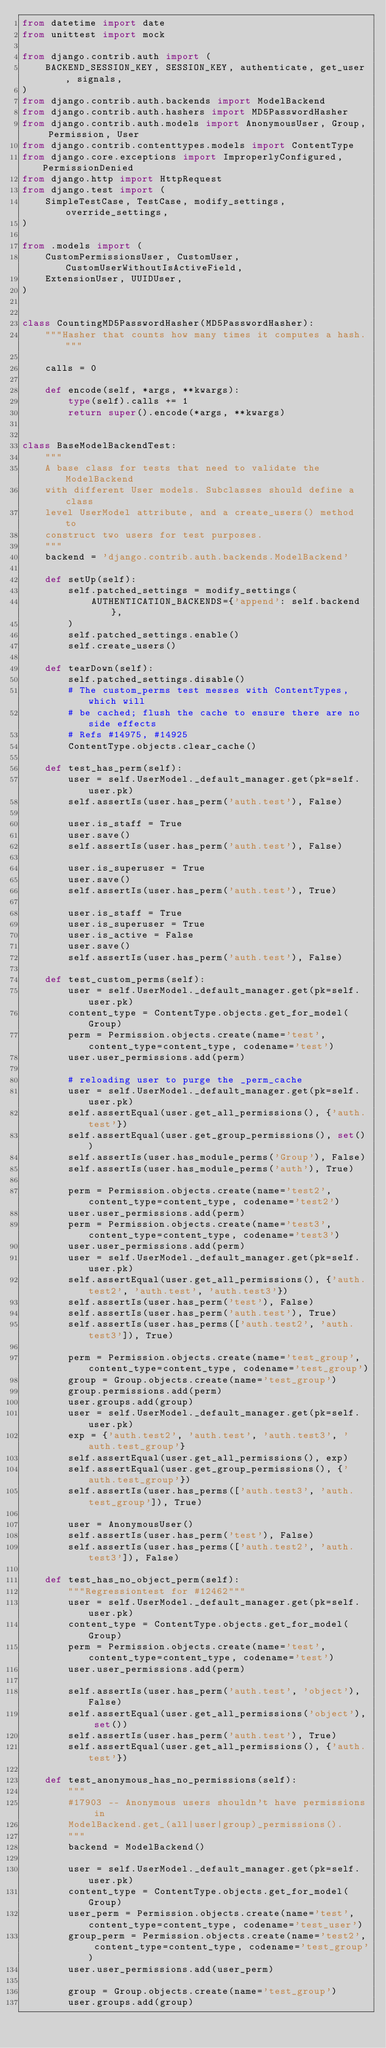<code> <loc_0><loc_0><loc_500><loc_500><_Python_>from datetime import date
from unittest import mock

from django.contrib.auth import (
    BACKEND_SESSION_KEY, SESSION_KEY, authenticate, get_user, signals,
)
from django.contrib.auth.backends import ModelBackend
from django.contrib.auth.hashers import MD5PasswordHasher
from django.contrib.auth.models import AnonymousUser, Group, Permission, User
from django.contrib.contenttypes.models import ContentType
from django.core.exceptions import ImproperlyConfigured, PermissionDenied
from django.http import HttpRequest
from django.test import (
    SimpleTestCase, TestCase, modify_settings, override_settings,
)

from .models import (
    CustomPermissionsUser, CustomUser, CustomUserWithoutIsActiveField,
    ExtensionUser, UUIDUser,
)


class CountingMD5PasswordHasher(MD5PasswordHasher):
    """Hasher that counts how many times it computes a hash."""

    calls = 0

    def encode(self, *args, **kwargs):
        type(self).calls += 1
        return super().encode(*args, **kwargs)


class BaseModelBackendTest:
    """
    A base class for tests that need to validate the ModelBackend
    with different User models. Subclasses should define a class
    level UserModel attribute, and a create_users() method to
    construct two users for test purposes.
    """
    backend = 'django.contrib.auth.backends.ModelBackend'

    def setUp(self):
        self.patched_settings = modify_settings(
            AUTHENTICATION_BACKENDS={'append': self.backend},
        )
        self.patched_settings.enable()
        self.create_users()

    def tearDown(self):
        self.patched_settings.disable()
        # The custom_perms test messes with ContentTypes, which will
        # be cached; flush the cache to ensure there are no side effects
        # Refs #14975, #14925
        ContentType.objects.clear_cache()

    def test_has_perm(self):
        user = self.UserModel._default_manager.get(pk=self.user.pk)
        self.assertIs(user.has_perm('auth.test'), False)

        user.is_staff = True
        user.save()
        self.assertIs(user.has_perm('auth.test'), False)

        user.is_superuser = True
        user.save()
        self.assertIs(user.has_perm('auth.test'), True)

        user.is_staff = True
        user.is_superuser = True
        user.is_active = False
        user.save()
        self.assertIs(user.has_perm('auth.test'), False)

    def test_custom_perms(self):
        user = self.UserModel._default_manager.get(pk=self.user.pk)
        content_type = ContentType.objects.get_for_model(Group)
        perm = Permission.objects.create(name='test', content_type=content_type, codename='test')
        user.user_permissions.add(perm)

        # reloading user to purge the _perm_cache
        user = self.UserModel._default_manager.get(pk=self.user.pk)
        self.assertEqual(user.get_all_permissions(), {'auth.test'})
        self.assertEqual(user.get_group_permissions(), set())
        self.assertIs(user.has_module_perms('Group'), False)
        self.assertIs(user.has_module_perms('auth'), True)

        perm = Permission.objects.create(name='test2', content_type=content_type, codename='test2')
        user.user_permissions.add(perm)
        perm = Permission.objects.create(name='test3', content_type=content_type, codename='test3')
        user.user_permissions.add(perm)
        user = self.UserModel._default_manager.get(pk=self.user.pk)
        self.assertEqual(user.get_all_permissions(), {'auth.test2', 'auth.test', 'auth.test3'})
        self.assertIs(user.has_perm('test'), False)
        self.assertIs(user.has_perm('auth.test'), True)
        self.assertIs(user.has_perms(['auth.test2', 'auth.test3']), True)

        perm = Permission.objects.create(name='test_group', content_type=content_type, codename='test_group')
        group = Group.objects.create(name='test_group')
        group.permissions.add(perm)
        user.groups.add(group)
        user = self.UserModel._default_manager.get(pk=self.user.pk)
        exp = {'auth.test2', 'auth.test', 'auth.test3', 'auth.test_group'}
        self.assertEqual(user.get_all_permissions(), exp)
        self.assertEqual(user.get_group_permissions(), {'auth.test_group'})
        self.assertIs(user.has_perms(['auth.test3', 'auth.test_group']), True)

        user = AnonymousUser()
        self.assertIs(user.has_perm('test'), False)
        self.assertIs(user.has_perms(['auth.test2', 'auth.test3']), False)

    def test_has_no_object_perm(self):
        """Regressiontest for #12462"""
        user = self.UserModel._default_manager.get(pk=self.user.pk)
        content_type = ContentType.objects.get_for_model(Group)
        perm = Permission.objects.create(name='test', content_type=content_type, codename='test')
        user.user_permissions.add(perm)

        self.assertIs(user.has_perm('auth.test', 'object'), False)
        self.assertEqual(user.get_all_permissions('object'), set())
        self.assertIs(user.has_perm('auth.test'), True)
        self.assertEqual(user.get_all_permissions(), {'auth.test'})

    def test_anonymous_has_no_permissions(self):
        """
        #17903 -- Anonymous users shouldn't have permissions in
        ModelBackend.get_(all|user|group)_permissions().
        """
        backend = ModelBackend()

        user = self.UserModel._default_manager.get(pk=self.user.pk)
        content_type = ContentType.objects.get_for_model(Group)
        user_perm = Permission.objects.create(name='test', content_type=content_type, codename='test_user')
        group_perm = Permission.objects.create(name='test2', content_type=content_type, codename='test_group')
        user.user_permissions.add(user_perm)

        group = Group.objects.create(name='test_group')
        user.groups.add(group)</code> 